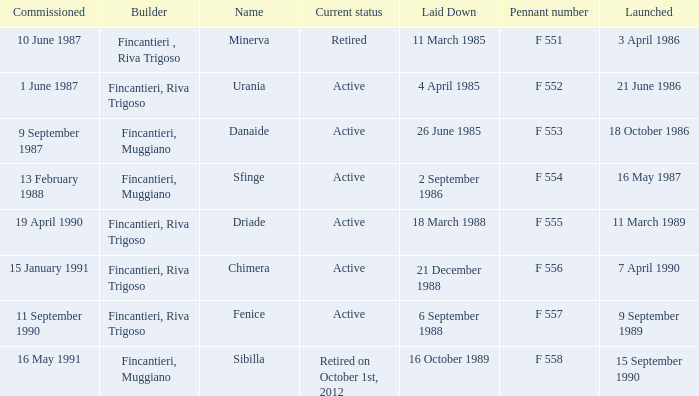What builder is now retired F 551. 